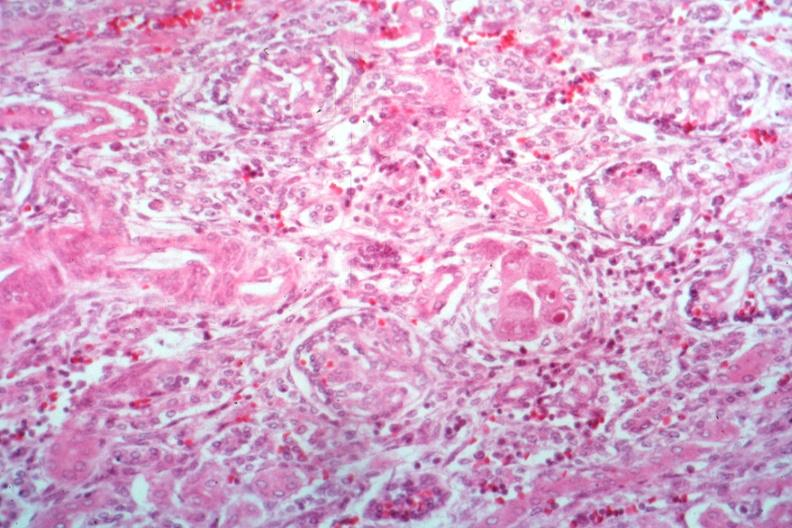where is this?
Answer the question using a single word or phrase. Urinary 